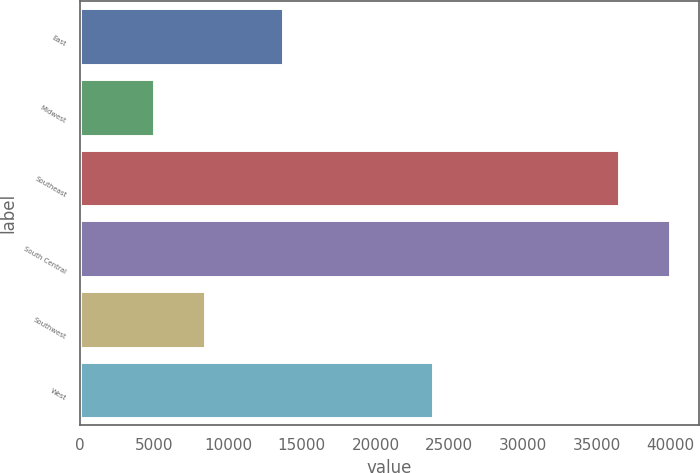Convert chart. <chart><loc_0><loc_0><loc_500><loc_500><bar_chart><fcel>East<fcel>Midwest<fcel>Southeast<fcel>South Central<fcel>Southwest<fcel>West<nl><fcel>13700<fcel>5000<fcel>36500<fcel>39920<fcel>8420<fcel>23900<nl></chart> 